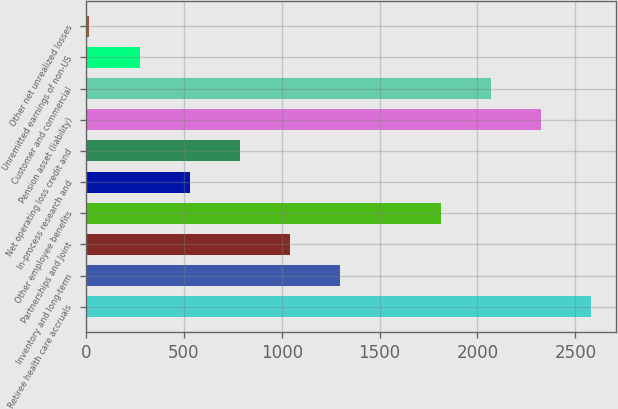<chart> <loc_0><loc_0><loc_500><loc_500><bar_chart><fcel>Retiree health care accruals<fcel>Inventory and long-term<fcel>Partnerships and Joint<fcel>Other employee benefits<fcel>In-process research and<fcel>Net operating loss credit and<fcel>Pension asset (liability)<fcel>Customer and commercial<fcel>Unremitted earnings of non-US<fcel>Other net unrealized losses<nl><fcel>2581<fcel>1299.5<fcel>1043.2<fcel>1812.1<fcel>530.6<fcel>786.9<fcel>2324.7<fcel>2068.4<fcel>274.3<fcel>18<nl></chart> 